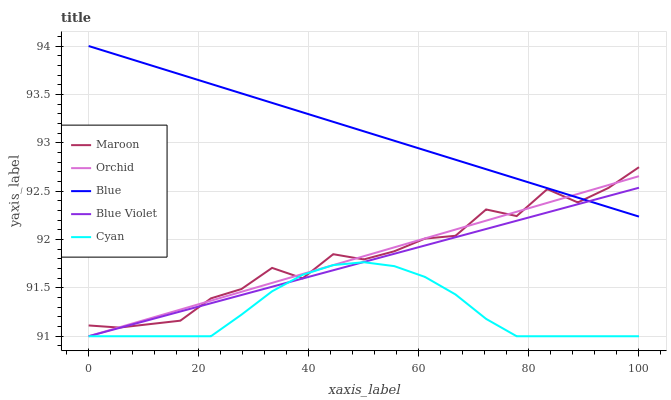Does Blue Violet have the minimum area under the curve?
Answer yes or no. No. Does Blue Violet have the maximum area under the curve?
Answer yes or no. No. Is Cyan the smoothest?
Answer yes or no. No. Is Cyan the roughest?
Answer yes or no. No. Does Maroon have the lowest value?
Answer yes or no. No. Does Blue Violet have the highest value?
Answer yes or no. No. Is Cyan less than Blue?
Answer yes or no. Yes. Is Blue greater than Cyan?
Answer yes or no. Yes. Does Cyan intersect Blue?
Answer yes or no. No. 